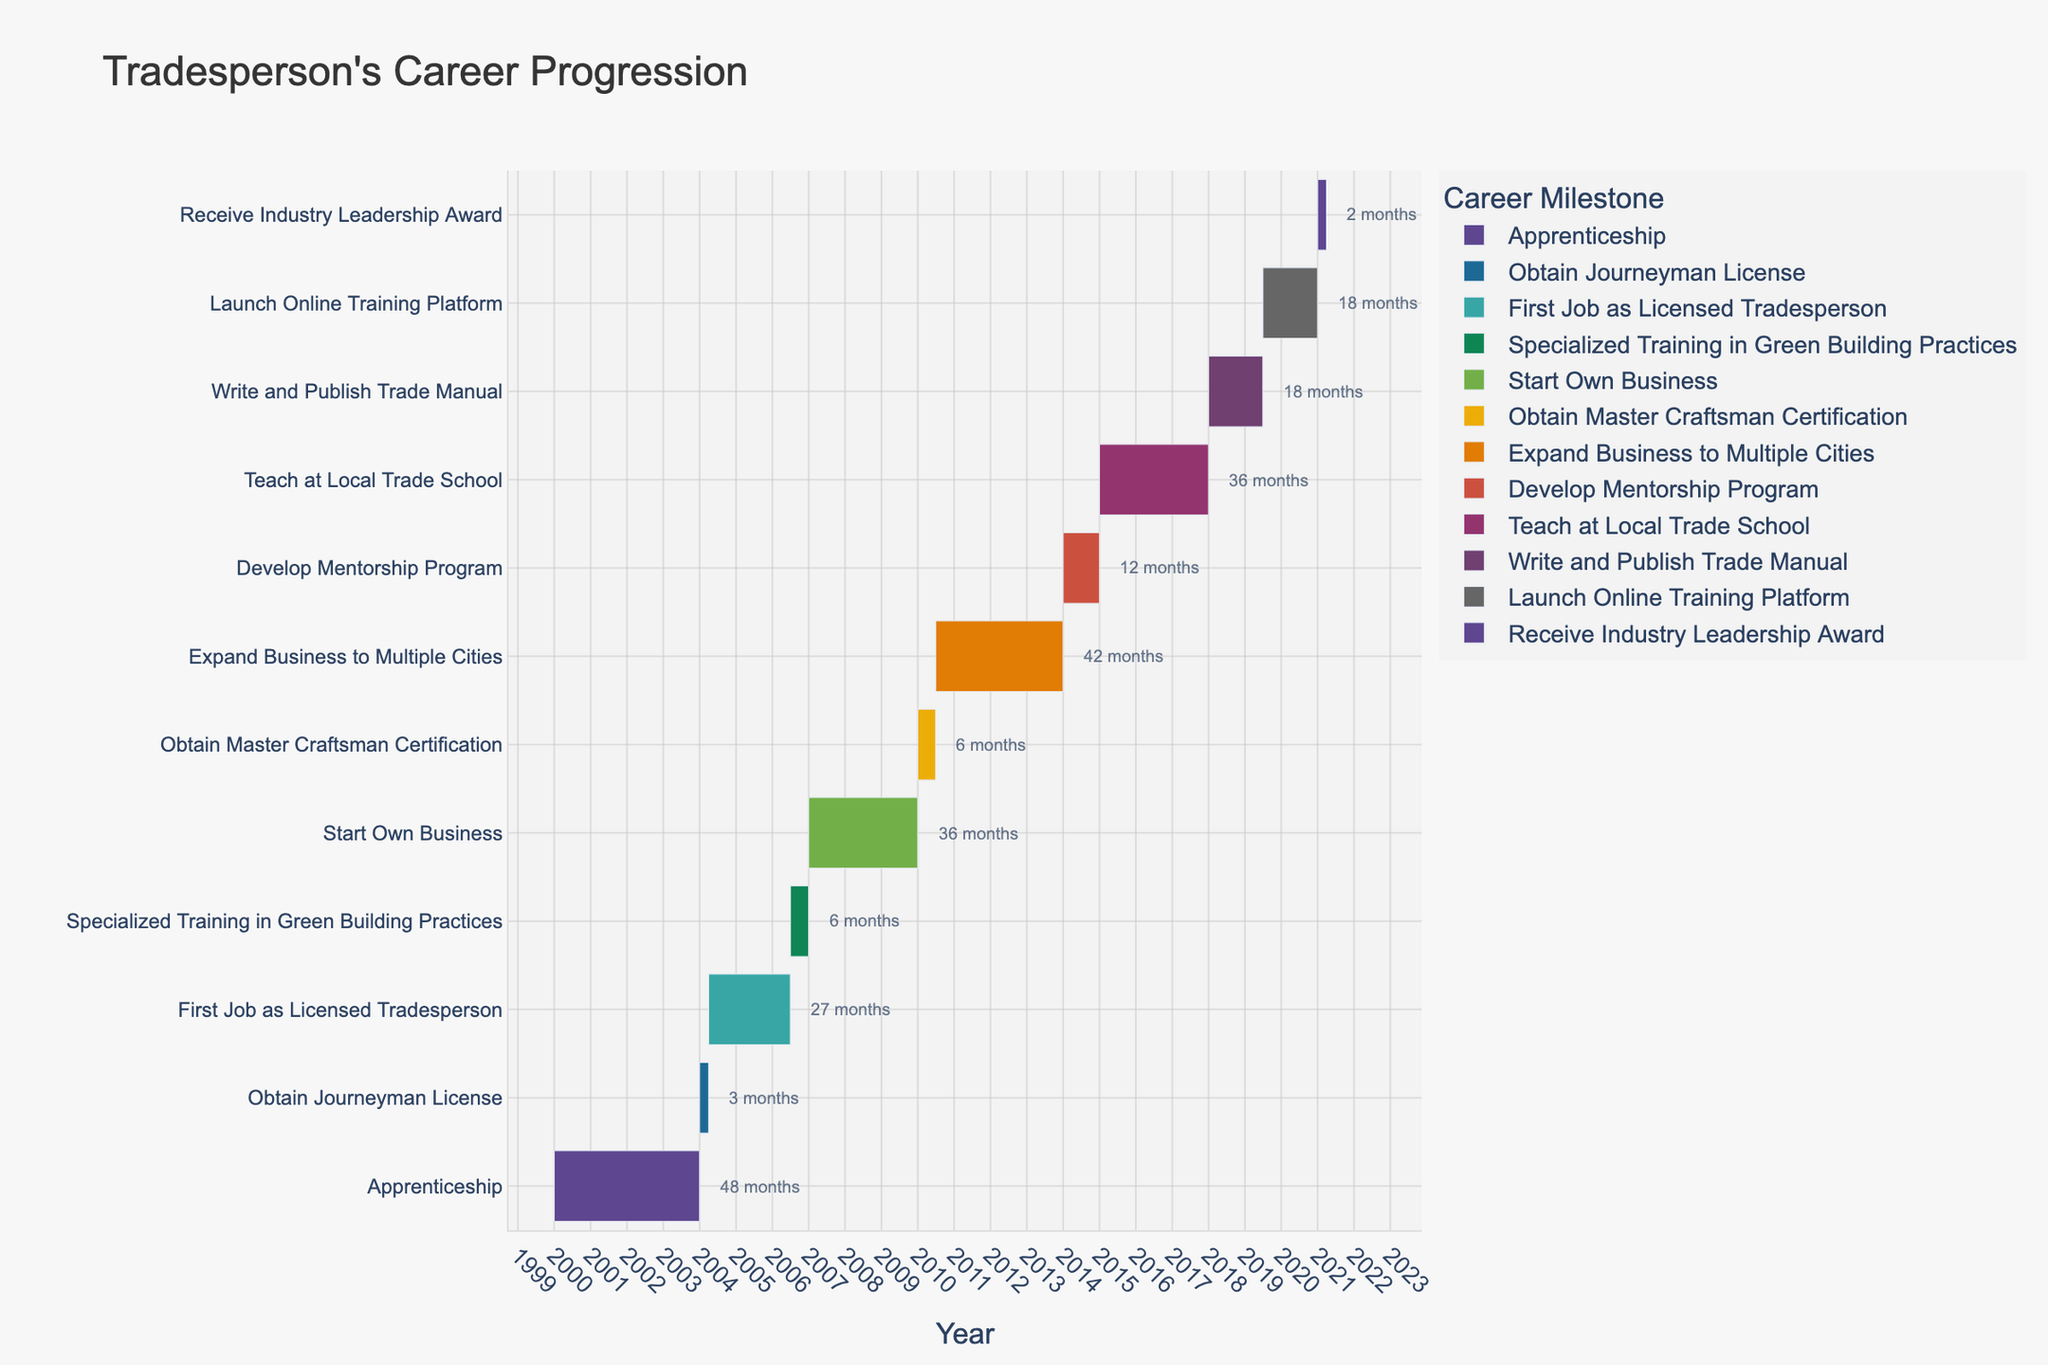What's the title of the Gantt chart? The title is always found at the top of the chart and usually provides a brief description of what the chart shows or represents.
Answer: Tradesperson's Career Progression What is the first milestone in the career progression? The first milestone in the chart is typically the earliest task listed on the y-axis, starting at the very bottom if the y-axis is reversed.
Answer: Apprenticeship How many months did the apprenticeship last? To determine the duration, subtract the start date from the end date of the apprenticeship, converting the result into months. January 2000 to December 2003 is 4 years, which equals 48 months.
Answer: 48 months When did the task "Expand Business to Multiple Cities" start and end? Refer to the timeline bar labeled "Expand Business to Multiple Cities" and note the start and end dates indicated by the beginning and end of the bar.
Answer: July 2010 to December 2013 Which task took the least amount of time to complete? To find the shortest task, compare the length of each task's timeline bar, with the smallest one representing the least duration.
Answer: Receive Industry Leadership Award Which milestones overlap ever so slightly in time? Look for tasks with timeline bars that intersect slightly; the bars "Obtain Master Craftsman Certification" and "Expand Business to Multiple Cities" overlap in mid-2010.
Answer: Obtain Master Craftsman Certification and Expand Business to Multiple Cities How long did the "Write and Publish Trade Manual" task take compared to the "Specialized Training in Green Building Practices"? Calculate the duration of each task in months, then compare them to see which took longer. "Write and Publish Trade Manual" spans 18 months from January 2018 to June 2019, while "Specialized Training in Green Building Practices" spans 6 months from July 2006 to December 2006.
Answer: Write and Publish Trade Manual took 12 months longer What was the longest milestone achieved? The longest milestone has the longest timeline bar representing its duration.
Answer: Expand Business to Multiple Cities Which milestone marks the transition from working for others to becoming self-employed? Typically, starting a business signifies moving from employment to self-employment. Look for tasks related to starting or owning a business.
Answer: Start Own Business 